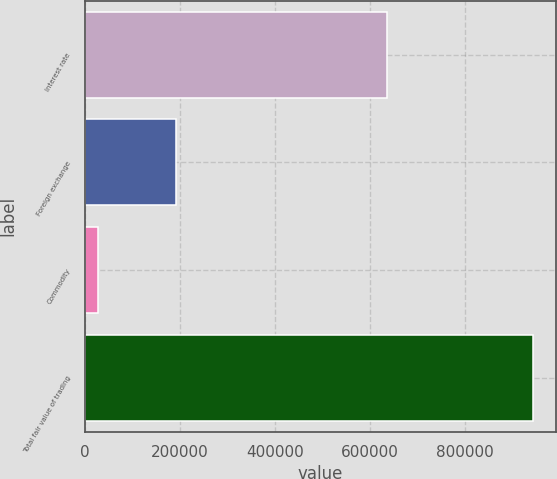Convert chart to OTSL. <chart><loc_0><loc_0><loc_500><loc_500><bar_chart><fcel>Interest rate<fcel>Foreign exchange<fcel>Commodity<fcel>Total fair value of trading<nl><fcel>635166<fcel>190900<fcel>27654<fcel>942912<nl></chart> 